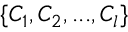Convert formula to latex. <formula><loc_0><loc_0><loc_500><loc_500>\{ C _ { 1 } , C _ { 2 } , \dots , C _ { l } \}</formula> 